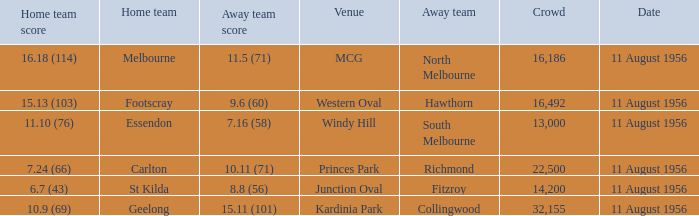Give me the full table as a dictionary. {'header': ['Home team score', 'Home team', 'Away team score', 'Venue', 'Away team', 'Crowd', 'Date'], 'rows': [['16.18 (114)', 'Melbourne', '11.5 (71)', 'MCG', 'North Melbourne', '16,186', '11 August 1956'], ['15.13 (103)', 'Footscray', '9.6 (60)', 'Western Oval', 'Hawthorn', '16,492', '11 August 1956'], ['11.10 (76)', 'Essendon', '7.16 (58)', 'Windy Hill', 'South Melbourne', '13,000', '11 August 1956'], ['7.24 (66)', 'Carlton', '10.11 (71)', 'Princes Park', 'Richmond', '22,500', '11 August 1956'], ['6.7 (43)', 'St Kilda', '8.8 (56)', 'Junction Oval', 'Fitzroy', '14,200', '11 August 1956'], ['10.9 (69)', 'Geelong', '15.11 (101)', 'Kardinia Park', 'Collingwood', '32,155', '11 August 1956']]} Where did a home team score 10.9 (69)? Kardinia Park. 